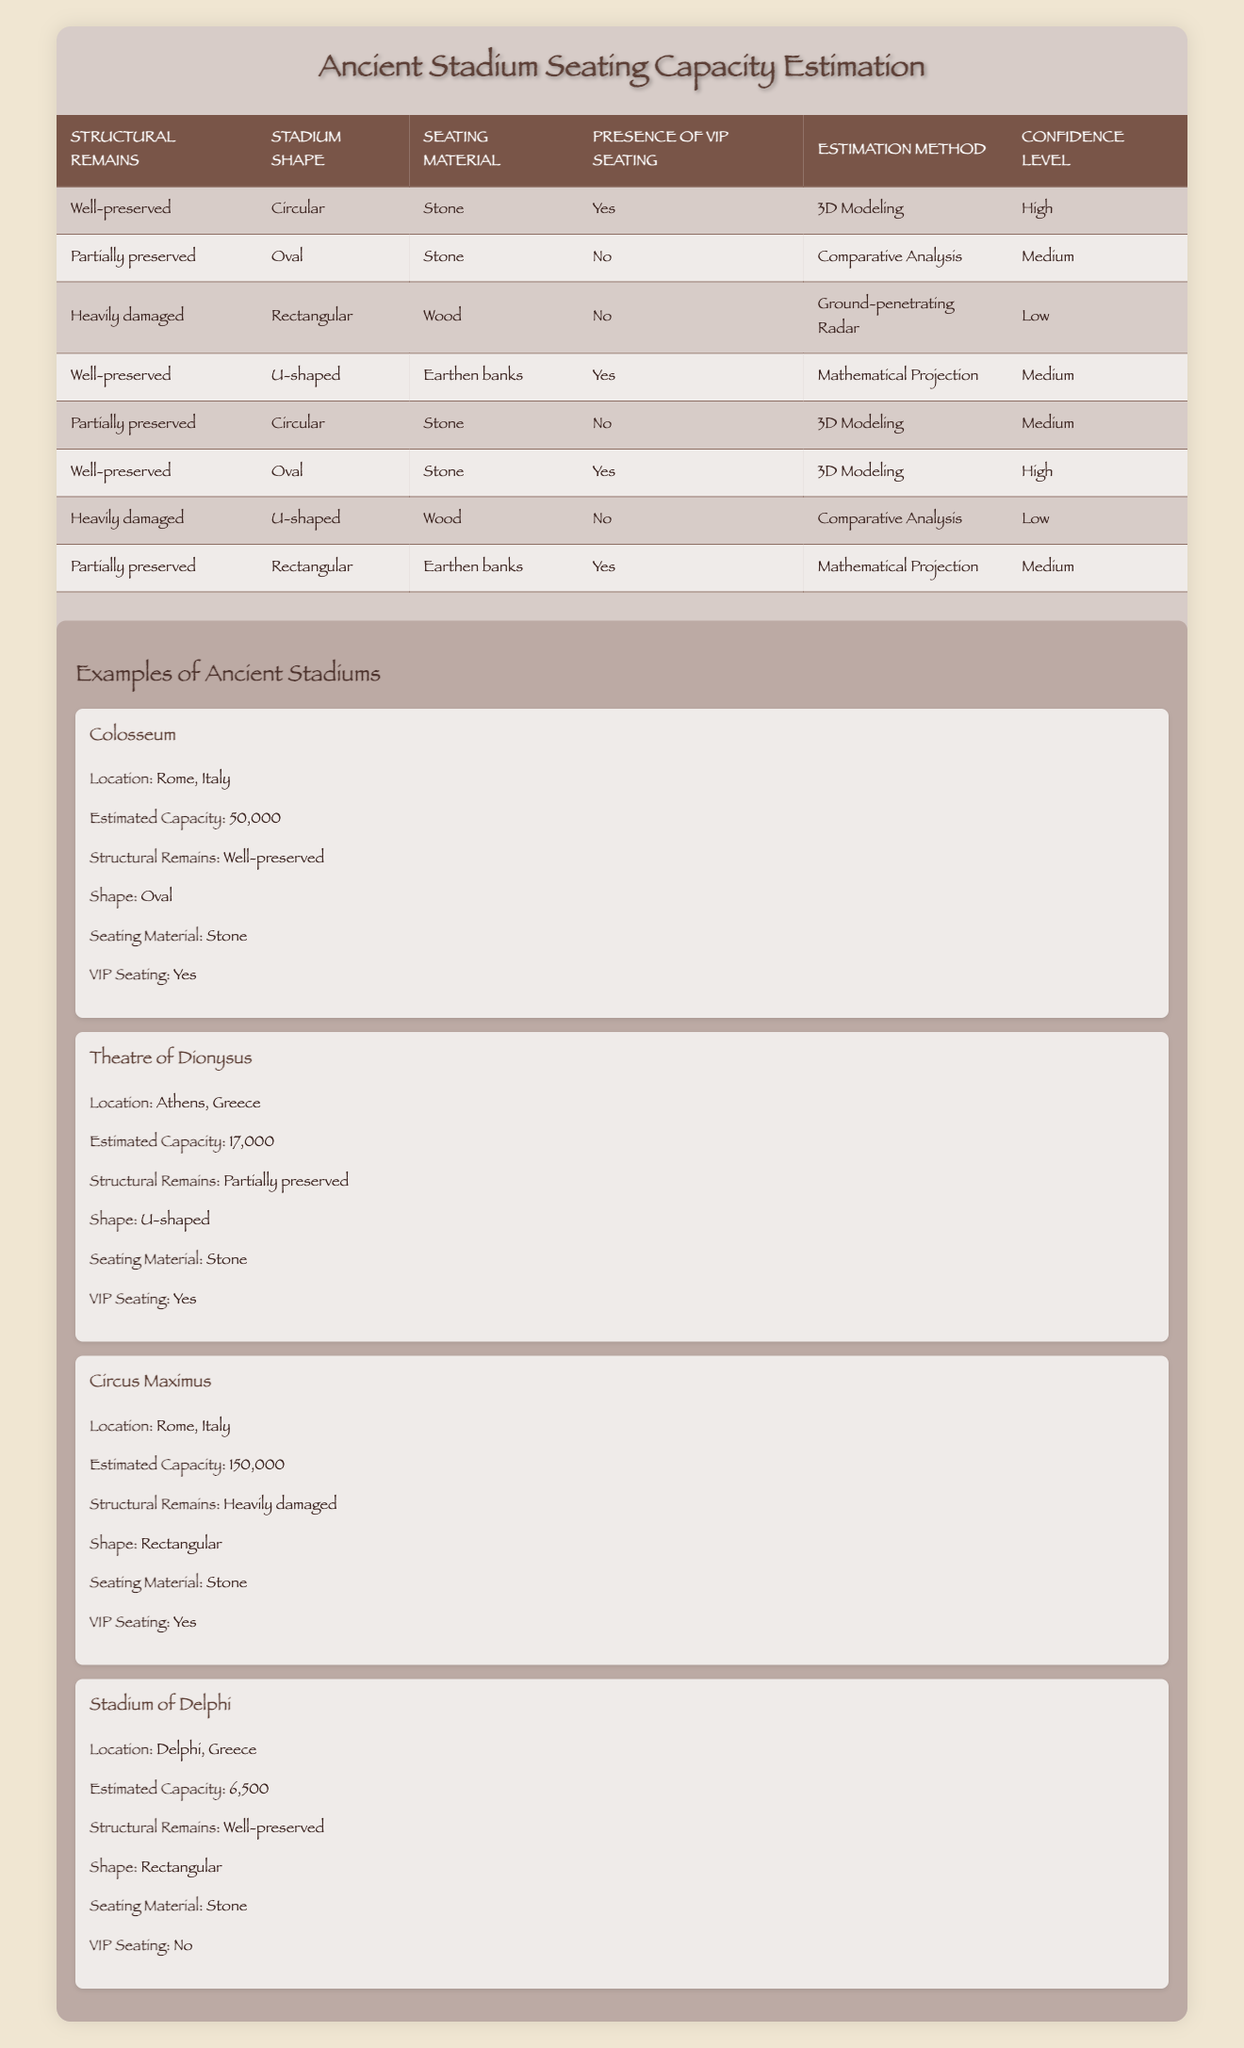What is the estimation method used for a well-preserved circular stadium with stone and VIP seating? According to the table, the estimation method for a well-preserved circular stadium made of stone and with VIP seating is specified as "3D Modeling."
Answer: 3D Modeling How many different estimation methods are listed in the table? The table includes four unique estimation methods: "3D Modeling," "Comparative Analysis," "Mathematical Projection," and "Ground-penetrating Radar." Thus, the answer is four different methods.
Answer: 4 Is the confidence level for the estimation method of a heavily damaged U-shaped stadium with wood and no VIP seating high? The table clearly states that for a heavily damaged U-shaped stadium made of wood and with no VIP seating, the confidence level is categorized as "Low." Therefore, the answer is no.
Answer: No What estimation method would be employed for a partially preserved rectangular stadium with earthen banks and VIP seating? According to the rules in the table, the estimation method for a partially preserved rectangular stadium made with earthen banks and having VIP seating is "Mathematical Projection."
Answer: Mathematical Projection Count the number of stadiums in the table that utilize stone as the seating material. Reviewing the table, we find that there are five stadiums utilizing stone as the seating material, indicated by their respective conditions. The total count is five.
Answer: 5 What is the confidence level for the stadium of Delphi? The stadium of Delphi is classified in the table as well-preserved, rectangular, using stone as the seating material, and having no VIP seating. According to the corresponding rule, the confidence level is "Medium."
Answer: Medium Is there any estimation method referred to as "Ground-penetrating Radar" that has a high confidence level among the listed stadiums? Checking the table reveals that the method "Ground-penetrating Radar" is associated with a heavily damaged rectangular stadium made of wood and with no VIP seating. The confidence level associated with this method is "Low," indicating that there is no instance of "Ground-penetrating Radar" with a high confidence level.
Answer: No Identify the stadium that is estimated to have the highest seating capacity according to the examples given. The table lists several stadiums with their estimated capacities; the "Circus Maximus" is noted with an estimated capacity of 150,000, which is the highest compared to the others in the examples.
Answer: Circus Maximus 